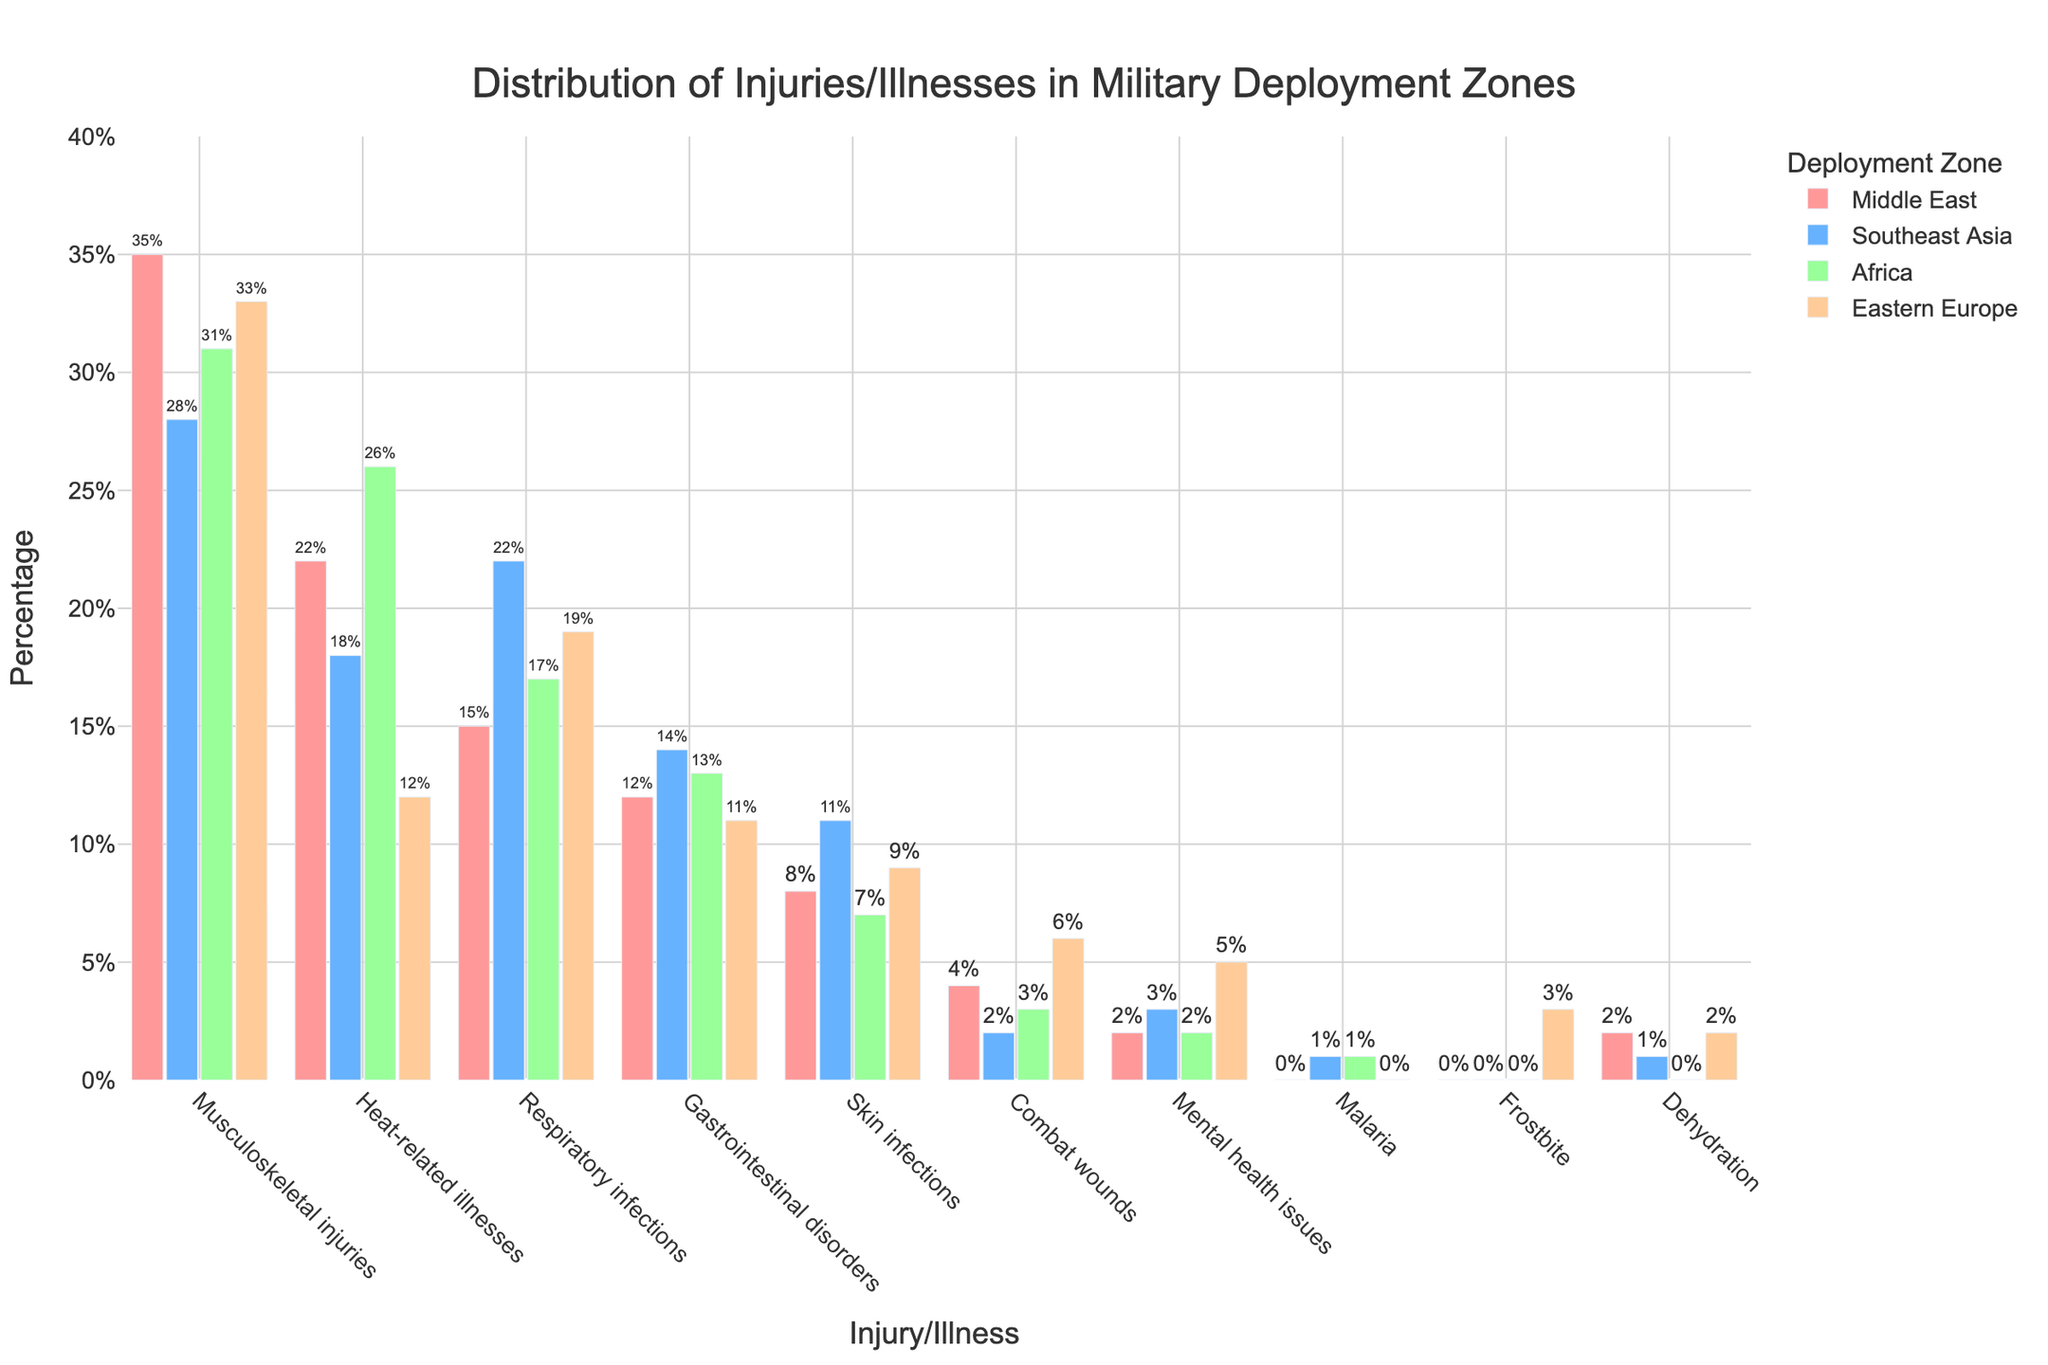Which deployment zone has the highest percentage of musculoskeletal injuries? By looking at the bar height for musculoskeletal injuries, we can see that the Middle East bar is the tallest.
Answer: Middle East How much higher is the percentage of heat-related illnesses in Africa compared to Eastern Europe? First, find the percentages for heat-related illnesses: Africa is 26%, and Eastern Europe is 12%. Then, subtract 12% from 26%.
Answer: 14% What is the sum of the percentages of gastrointestinal disorders across all deployment zones? Gastrointestinal disorder percentages are given for each zone: Middle East (12%), Southeast Asia (14%), Africa (13%), Eastern Europe (11%). Sum these values: 12% + 14% + 13% + 11% = 50%.
Answer: 50% Which injury/illness appears with the lowest percentage in the Middle East, and what is that percentage? By examining the Middle East column, the smallest percentage corresponds to combat wounds and malaria, both at 0%.
Answer: combat wounds (0%) Are there more mental health issues reported in Eastern Europe or the Middle East? Compare the bars for mental health issues: Eastern Europe is higher than the Middle East.
Answer: Eastern Europe Between skin infections and respiratory infections, which has a higher percentage in Southeast Asia? Look at the bar heights for skin infections and respiratory infections in Southeast Asia: respiratory infections have a higher percentage.
Answer: Respiratory infections What is the average percentage of dehydration cases across all deployment zones? First, find the percentages for dehydration: Middle East (2%), Southeast Asia (1%), Africa (0%), Eastern Europe (2%). Then, sum these values and divide by 4: (2% + 1% + 0% + 2%) / 4 = 1.25%.
Answer: 1.25% Which two deployment zones have the same percentage of respiratory infections? By comparing the percentages for respiratory infections, Africa (17%) and Eastern Europe (19%) do not match, but the Middle East (15%) and Southeast Asia (22%) do. Hence, there is no match here.
Answer: None How does the percentage of combat wounds in the Middle East compare to Africa? By comparing the bars for combat wounds: Middle East (4%) and Africa (3%), the Middle East has a higher percentage.
Answer: Middle East Which deployment zone reports the highest percentage of gastrointestinal disorders? By looking at the highest bar for gastrointestinal disorders, Southeast Asia reports the highest percentage.
Answer: Southeast Asia 